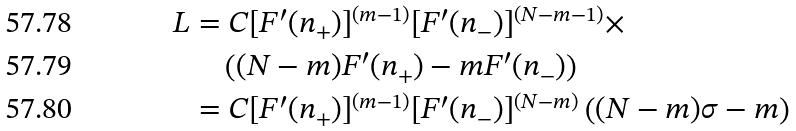<formula> <loc_0><loc_0><loc_500><loc_500>L & = C [ F ^ { \prime } ( n _ { + } ) ] ^ { ( m - 1 ) } [ F ^ { \prime } ( n _ { - } ) ] ^ { ( N - m - 1 ) } \times \\ & \quad \left ( ( N - m ) F ^ { \prime } ( n _ { + } ) - m F ^ { \prime } ( n _ { - } ) \right ) \\ & = C [ F ^ { \prime } ( n _ { + } ) ] ^ { ( m - 1 ) } [ F ^ { \prime } ( n _ { - } ) ] ^ { ( N - m ) } \left ( ( N - m ) \sigma - m \right )</formula> 